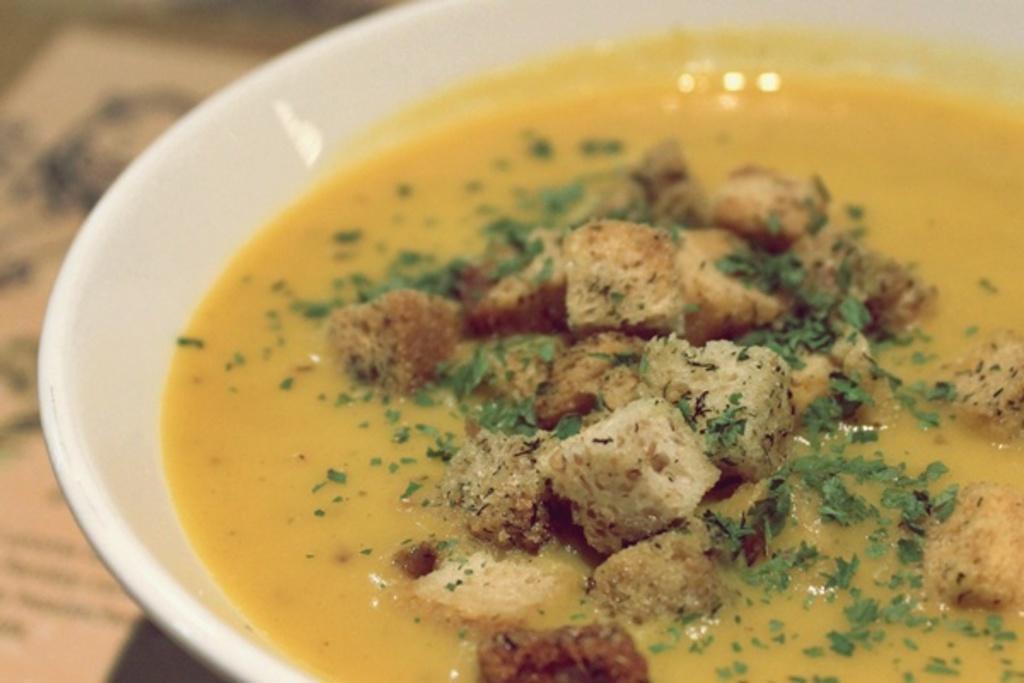How would you summarize this image in a sentence or two? In this image in the foreground there is one bowl, in the bowl there is some food and in the background there is some object. 